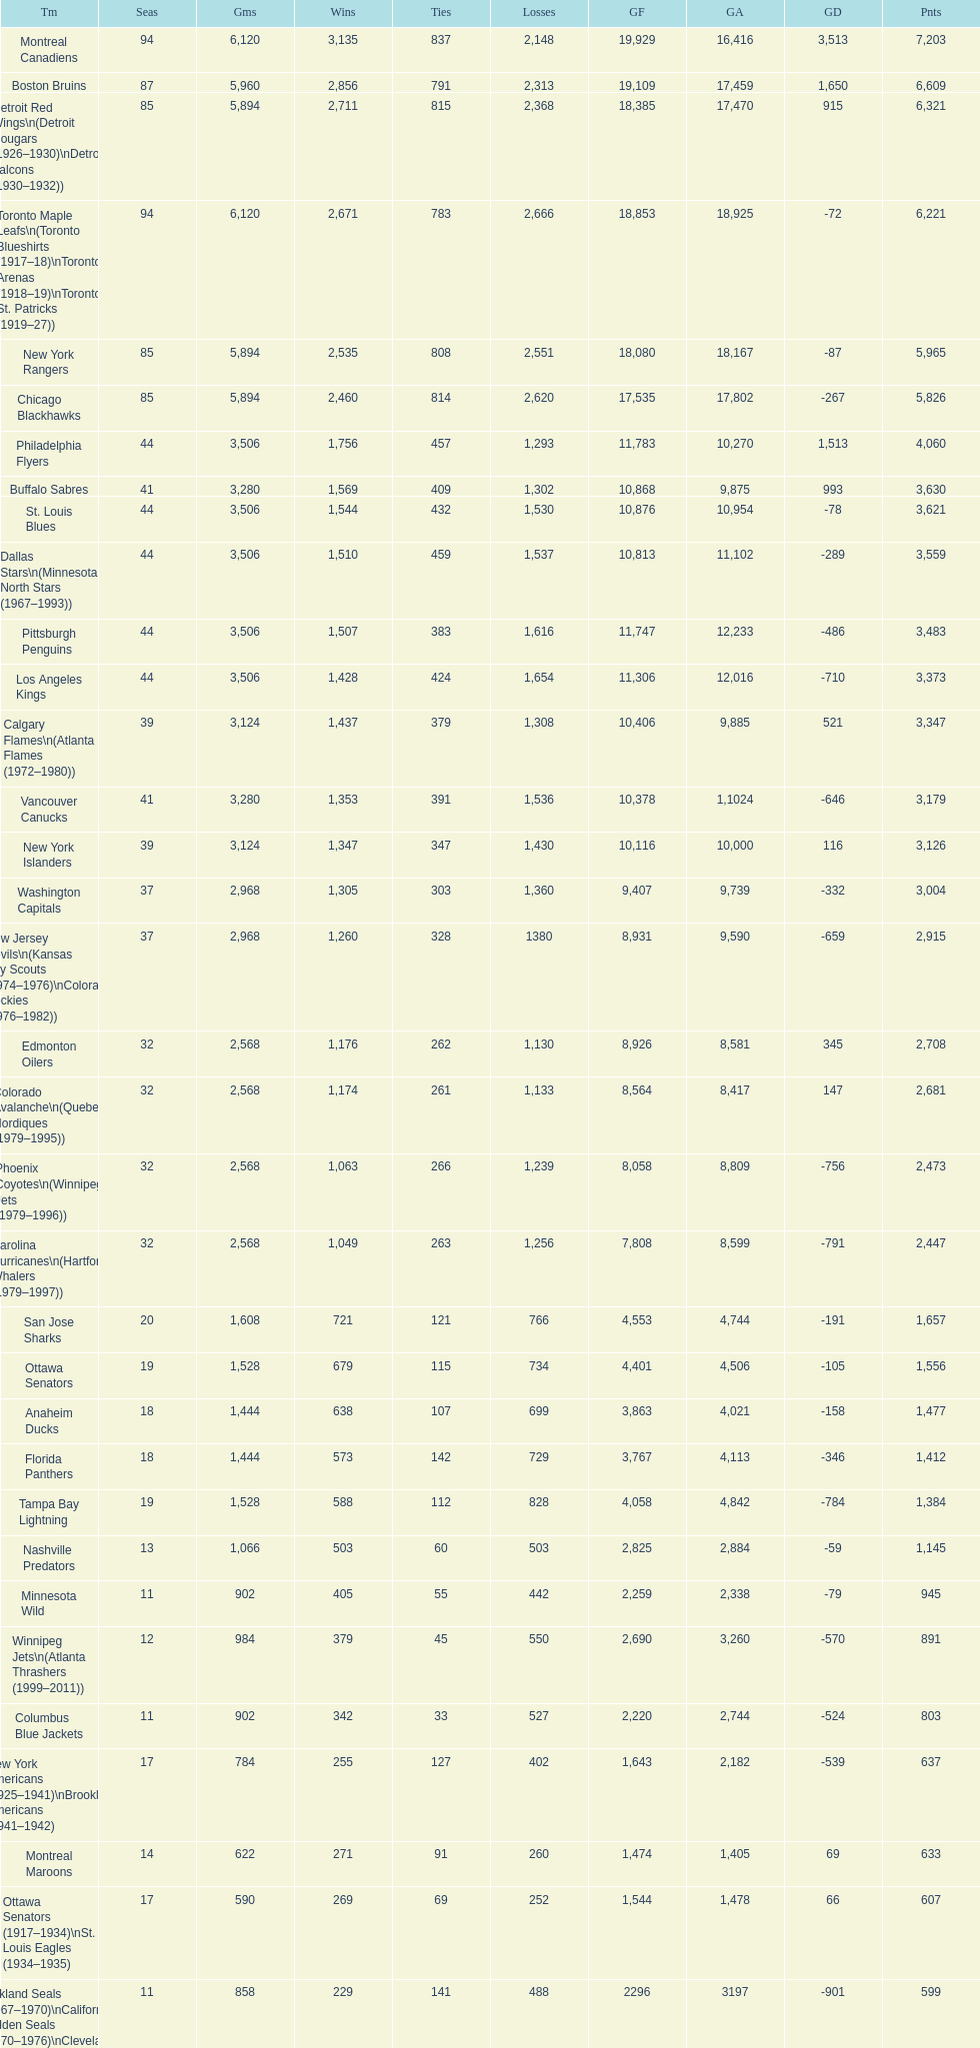What is the number of games that the vancouver canucks have won up to this point? 1,353. 